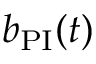<formula> <loc_0><loc_0><loc_500><loc_500>b _ { P I } ( t )</formula> 